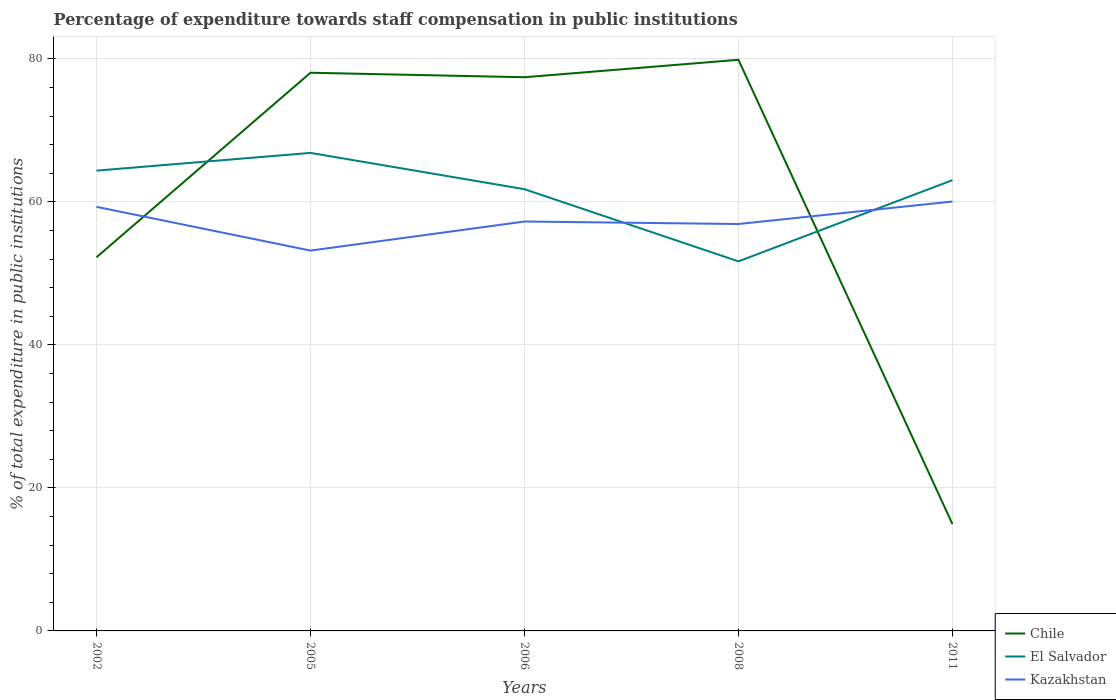How many different coloured lines are there?
Your answer should be very brief. 3. Does the line corresponding to El Salvador intersect with the line corresponding to Chile?
Offer a very short reply. Yes. Is the number of lines equal to the number of legend labels?
Provide a succinct answer. Yes. Across all years, what is the maximum percentage of expenditure towards staff compensation in Chile?
Offer a terse response. 14.95. In which year was the percentage of expenditure towards staff compensation in Chile maximum?
Make the answer very short. 2011. What is the total percentage of expenditure towards staff compensation in Chile in the graph?
Your answer should be compact. -2.44. What is the difference between the highest and the second highest percentage of expenditure towards staff compensation in Chile?
Your answer should be compact. 64.94. How many lines are there?
Offer a very short reply. 3. How many years are there in the graph?
Give a very brief answer. 5. Are the values on the major ticks of Y-axis written in scientific E-notation?
Your answer should be compact. No. Does the graph contain any zero values?
Your answer should be very brief. No. Does the graph contain grids?
Ensure brevity in your answer.  Yes. Where does the legend appear in the graph?
Provide a succinct answer. Bottom right. How many legend labels are there?
Provide a short and direct response. 3. What is the title of the graph?
Your response must be concise. Percentage of expenditure towards staff compensation in public institutions. Does "Belgium" appear as one of the legend labels in the graph?
Keep it short and to the point. No. What is the label or title of the Y-axis?
Provide a succinct answer. % of total expenditure in public institutions. What is the % of total expenditure in public institutions of Chile in 2002?
Give a very brief answer. 52.27. What is the % of total expenditure in public institutions in El Salvador in 2002?
Your response must be concise. 64.38. What is the % of total expenditure in public institutions of Kazakhstan in 2002?
Ensure brevity in your answer.  59.32. What is the % of total expenditure in public institutions in Chile in 2005?
Provide a short and direct response. 78.08. What is the % of total expenditure in public institutions in El Salvador in 2005?
Provide a succinct answer. 66.86. What is the % of total expenditure in public institutions of Kazakhstan in 2005?
Give a very brief answer. 53.2. What is the % of total expenditure in public institutions in Chile in 2006?
Your response must be concise. 77.45. What is the % of total expenditure in public institutions in El Salvador in 2006?
Provide a succinct answer. 61.79. What is the % of total expenditure in public institutions in Kazakhstan in 2006?
Offer a terse response. 57.27. What is the % of total expenditure in public institutions in Chile in 2008?
Your answer should be very brief. 79.89. What is the % of total expenditure in public institutions in El Salvador in 2008?
Your answer should be very brief. 51.69. What is the % of total expenditure in public institutions in Kazakhstan in 2008?
Offer a terse response. 56.92. What is the % of total expenditure in public institutions in Chile in 2011?
Ensure brevity in your answer.  14.95. What is the % of total expenditure in public institutions of El Salvador in 2011?
Keep it short and to the point. 63.05. What is the % of total expenditure in public institutions in Kazakhstan in 2011?
Ensure brevity in your answer.  60.06. Across all years, what is the maximum % of total expenditure in public institutions in Chile?
Provide a succinct answer. 79.89. Across all years, what is the maximum % of total expenditure in public institutions in El Salvador?
Ensure brevity in your answer.  66.86. Across all years, what is the maximum % of total expenditure in public institutions in Kazakhstan?
Your response must be concise. 60.06. Across all years, what is the minimum % of total expenditure in public institutions of Chile?
Keep it short and to the point. 14.95. Across all years, what is the minimum % of total expenditure in public institutions in El Salvador?
Provide a short and direct response. 51.69. Across all years, what is the minimum % of total expenditure in public institutions of Kazakhstan?
Ensure brevity in your answer.  53.2. What is the total % of total expenditure in public institutions of Chile in the graph?
Your answer should be compact. 302.63. What is the total % of total expenditure in public institutions in El Salvador in the graph?
Provide a short and direct response. 307.77. What is the total % of total expenditure in public institutions in Kazakhstan in the graph?
Ensure brevity in your answer.  286.76. What is the difference between the % of total expenditure in public institutions of Chile in 2002 and that in 2005?
Your response must be concise. -25.81. What is the difference between the % of total expenditure in public institutions of El Salvador in 2002 and that in 2005?
Your answer should be compact. -2.48. What is the difference between the % of total expenditure in public institutions in Kazakhstan in 2002 and that in 2005?
Ensure brevity in your answer.  6.12. What is the difference between the % of total expenditure in public institutions in Chile in 2002 and that in 2006?
Provide a short and direct response. -25.18. What is the difference between the % of total expenditure in public institutions of El Salvador in 2002 and that in 2006?
Keep it short and to the point. 2.59. What is the difference between the % of total expenditure in public institutions of Kazakhstan in 2002 and that in 2006?
Your answer should be very brief. 2.05. What is the difference between the % of total expenditure in public institutions of Chile in 2002 and that in 2008?
Give a very brief answer. -27.62. What is the difference between the % of total expenditure in public institutions in El Salvador in 2002 and that in 2008?
Ensure brevity in your answer.  12.69. What is the difference between the % of total expenditure in public institutions in Kazakhstan in 2002 and that in 2008?
Provide a short and direct response. 2.4. What is the difference between the % of total expenditure in public institutions in Chile in 2002 and that in 2011?
Keep it short and to the point. 37.32. What is the difference between the % of total expenditure in public institutions in El Salvador in 2002 and that in 2011?
Provide a short and direct response. 1.33. What is the difference between the % of total expenditure in public institutions of Kazakhstan in 2002 and that in 2011?
Provide a short and direct response. -0.74. What is the difference between the % of total expenditure in public institutions in Chile in 2005 and that in 2006?
Make the answer very short. 0.63. What is the difference between the % of total expenditure in public institutions of El Salvador in 2005 and that in 2006?
Provide a succinct answer. 5.08. What is the difference between the % of total expenditure in public institutions of Kazakhstan in 2005 and that in 2006?
Keep it short and to the point. -4.07. What is the difference between the % of total expenditure in public institutions in Chile in 2005 and that in 2008?
Your response must be concise. -1.81. What is the difference between the % of total expenditure in public institutions of El Salvador in 2005 and that in 2008?
Give a very brief answer. 15.17. What is the difference between the % of total expenditure in public institutions in Kazakhstan in 2005 and that in 2008?
Give a very brief answer. -3.72. What is the difference between the % of total expenditure in public institutions in Chile in 2005 and that in 2011?
Your response must be concise. 63.13. What is the difference between the % of total expenditure in public institutions of El Salvador in 2005 and that in 2011?
Make the answer very short. 3.81. What is the difference between the % of total expenditure in public institutions in Kazakhstan in 2005 and that in 2011?
Offer a very short reply. -6.86. What is the difference between the % of total expenditure in public institutions of Chile in 2006 and that in 2008?
Keep it short and to the point. -2.44. What is the difference between the % of total expenditure in public institutions of El Salvador in 2006 and that in 2008?
Ensure brevity in your answer.  10.09. What is the difference between the % of total expenditure in public institutions in Kazakhstan in 2006 and that in 2008?
Keep it short and to the point. 0.35. What is the difference between the % of total expenditure in public institutions in Chile in 2006 and that in 2011?
Provide a succinct answer. 62.5. What is the difference between the % of total expenditure in public institutions of El Salvador in 2006 and that in 2011?
Give a very brief answer. -1.26. What is the difference between the % of total expenditure in public institutions in Kazakhstan in 2006 and that in 2011?
Provide a short and direct response. -2.8. What is the difference between the % of total expenditure in public institutions in Chile in 2008 and that in 2011?
Your answer should be compact. 64.94. What is the difference between the % of total expenditure in public institutions in El Salvador in 2008 and that in 2011?
Your answer should be very brief. -11.36. What is the difference between the % of total expenditure in public institutions of Kazakhstan in 2008 and that in 2011?
Provide a succinct answer. -3.15. What is the difference between the % of total expenditure in public institutions of Chile in 2002 and the % of total expenditure in public institutions of El Salvador in 2005?
Keep it short and to the point. -14.6. What is the difference between the % of total expenditure in public institutions in Chile in 2002 and the % of total expenditure in public institutions in Kazakhstan in 2005?
Your answer should be very brief. -0.93. What is the difference between the % of total expenditure in public institutions of El Salvador in 2002 and the % of total expenditure in public institutions of Kazakhstan in 2005?
Make the answer very short. 11.18. What is the difference between the % of total expenditure in public institutions in Chile in 2002 and the % of total expenditure in public institutions in El Salvador in 2006?
Provide a succinct answer. -9.52. What is the difference between the % of total expenditure in public institutions of Chile in 2002 and the % of total expenditure in public institutions of Kazakhstan in 2006?
Offer a very short reply. -5. What is the difference between the % of total expenditure in public institutions of El Salvador in 2002 and the % of total expenditure in public institutions of Kazakhstan in 2006?
Give a very brief answer. 7.12. What is the difference between the % of total expenditure in public institutions of Chile in 2002 and the % of total expenditure in public institutions of El Salvador in 2008?
Offer a terse response. 0.58. What is the difference between the % of total expenditure in public institutions in Chile in 2002 and the % of total expenditure in public institutions in Kazakhstan in 2008?
Make the answer very short. -4.65. What is the difference between the % of total expenditure in public institutions of El Salvador in 2002 and the % of total expenditure in public institutions of Kazakhstan in 2008?
Provide a succinct answer. 7.46. What is the difference between the % of total expenditure in public institutions of Chile in 2002 and the % of total expenditure in public institutions of El Salvador in 2011?
Ensure brevity in your answer.  -10.78. What is the difference between the % of total expenditure in public institutions of Chile in 2002 and the % of total expenditure in public institutions of Kazakhstan in 2011?
Your response must be concise. -7.79. What is the difference between the % of total expenditure in public institutions of El Salvador in 2002 and the % of total expenditure in public institutions of Kazakhstan in 2011?
Your answer should be very brief. 4.32. What is the difference between the % of total expenditure in public institutions of Chile in 2005 and the % of total expenditure in public institutions of El Salvador in 2006?
Your answer should be very brief. 16.29. What is the difference between the % of total expenditure in public institutions in Chile in 2005 and the % of total expenditure in public institutions in Kazakhstan in 2006?
Offer a terse response. 20.81. What is the difference between the % of total expenditure in public institutions of El Salvador in 2005 and the % of total expenditure in public institutions of Kazakhstan in 2006?
Your response must be concise. 9.6. What is the difference between the % of total expenditure in public institutions of Chile in 2005 and the % of total expenditure in public institutions of El Salvador in 2008?
Keep it short and to the point. 26.39. What is the difference between the % of total expenditure in public institutions of Chile in 2005 and the % of total expenditure in public institutions of Kazakhstan in 2008?
Keep it short and to the point. 21.16. What is the difference between the % of total expenditure in public institutions of El Salvador in 2005 and the % of total expenditure in public institutions of Kazakhstan in 2008?
Your answer should be very brief. 9.95. What is the difference between the % of total expenditure in public institutions in Chile in 2005 and the % of total expenditure in public institutions in El Salvador in 2011?
Offer a very short reply. 15.03. What is the difference between the % of total expenditure in public institutions in Chile in 2005 and the % of total expenditure in public institutions in Kazakhstan in 2011?
Keep it short and to the point. 18.02. What is the difference between the % of total expenditure in public institutions in El Salvador in 2005 and the % of total expenditure in public institutions in Kazakhstan in 2011?
Give a very brief answer. 6.8. What is the difference between the % of total expenditure in public institutions in Chile in 2006 and the % of total expenditure in public institutions in El Salvador in 2008?
Give a very brief answer. 25.76. What is the difference between the % of total expenditure in public institutions of Chile in 2006 and the % of total expenditure in public institutions of Kazakhstan in 2008?
Give a very brief answer. 20.53. What is the difference between the % of total expenditure in public institutions of El Salvador in 2006 and the % of total expenditure in public institutions of Kazakhstan in 2008?
Offer a terse response. 4.87. What is the difference between the % of total expenditure in public institutions of Chile in 2006 and the % of total expenditure in public institutions of El Salvador in 2011?
Keep it short and to the point. 14.4. What is the difference between the % of total expenditure in public institutions of Chile in 2006 and the % of total expenditure in public institutions of Kazakhstan in 2011?
Ensure brevity in your answer.  17.39. What is the difference between the % of total expenditure in public institutions of El Salvador in 2006 and the % of total expenditure in public institutions of Kazakhstan in 2011?
Give a very brief answer. 1.72. What is the difference between the % of total expenditure in public institutions in Chile in 2008 and the % of total expenditure in public institutions in El Salvador in 2011?
Make the answer very short. 16.84. What is the difference between the % of total expenditure in public institutions of Chile in 2008 and the % of total expenditure in public institutions of Kazakhstan in 2011?
Your answer should be very brief. 19.83. What is the difference between the % of total expenditure in public institutions in El Salvador in 2008 and the % of total expenditure in public institutions in Kazakhstan in 2011?
Your response must be concise. -8.37. What is the average % of total expenditure in public institutions of Chile per year?
Provide a succinct answer. 60.53. What is the average % of total expenditure in public institutions in El Salvador per year?
Give a very brief answer. 61.55. What is the average % of total expenditure in public institutions of Kazakhstan per year?
Your response must be concise. 57.35. In the year 2002, what is the difference between the % of total expenditure in public institutions in Chile and % of total expenditure in public institutions in El Salvador?
Make the answer very short. -12.11. In the year 2002, what is the difference between the % of total expenditure in public institutions in Chile and % of total expenditure in public institutions in Kazakhstan?
Your answer should be very brief. -7.05. In the year 2002, what is the difference between the % of total expenditure in public institutions in El Salvador and % of total expenditure in public institutions in Kazakhstan?
Your response must be concise. 5.06. In the year 2005, what is the difference between the % of total expenditure in public institutions of Chile and % of total expenditure in public institutions of El Salvador?
Your answer should be very brief. 11.21. In the year 2005, what is the difference between the % of total expenditure in public institutions in Chile and % of total expenditure in public institutions in Kazakhstan?
Provide a succinct answer. 24.88. In the year 2005, what is the difference between the % of total expenditure in public institutions of El Salvador and % of total expenditure in public institutions of Kazakhstan?
Your answer should be compact. 13.67. In the year 2006, what is the difference between the % of total expenditure in public institutions of Chile and % of total expenditure in public institutions of El Salvador?
Your answer should be very brief. 15.66. In the year 2006, what is the difference between the % of total expenditure in public institutions in Chile and % of total expenditure in public institutions in Kazakhstan?
Make the answer very short. 20.18. In the year 2006, what is the difference between the % of total expenditure in public institutions of El Salvador and % of total expenditure in public institutions of Kazakhstan?
Provide a short and direct response. 4.52. In the year 2008, what is the difference between the % of total expenditure in public institutions in Chile and % of total expenditure in public institutions in El Salvador?
Your answer should be compact. 28.2. In the year 2008, what is the difference between the % of total expenditure in public institutions of Chile and % of total expenditure in public institutions of Kazakhstan?
Keep it short and to the point. 22.97. In the year 2008, what is the difference between the % of total expenditure in public institutions of El Salvador and % of total expenditure in public institutions of Kazakhstan?
Offer a very short reply. -5.22. In the year 2011, what is the difference between the % of total expenditure in public institutions in Chile and % of total expenditure in public institutions in El Salvador?
Your answer should be compact. -48.1. In the year 2011, what is the difference between the % of total expenditure in public institutions of Chile and % of total expenditure in public institutions of Kazakhstan?
Provide a short and direct response. -45.11. In the year 2011, what is the difference between the % of total expenditure in public institutions in El Salvador and % of total expenditure in public institutions in Kazakhstan?
Make the answer very short. 2.99. What is the ratio of the % of total expenditure in public institutions of Chile in 2002 to that in 2005?
Offer a very short reply. 0.67. What is the ratio of the % of total expenditure in public institutions of El Salvador in 2002 to that in 2005?
Your answer should be compact. 0.96. What is the ratio of the % of total expenditure in public institutions in Kazakhstan in 2002 to that in 2005?
Provide a succinct answer. 1.11. What is the ratio of the % of total expenditure in public institutions in Chile in 2002 to that in 2006?
Offer a terse response. 0.67. What is the ratio of the % of total expenditure in public institutions in El Salvador in 2002 to that in 2006?
Make the answer very short. 1.04. What is the ratio of the % of total expenditure in public institutions of Kazakhstan in 2002 to that in 2006?
Ensure brevity in your answer.  1.04. What is the ratio of the % of total expenditure in public institutions in Chile in 2002 to that in 2008?
Provide a succinct answer. 0.65. What is the ratio of the % of total expenditure in public institutions of El Salvador in 2002 to that in 2008?
Offer a terse response. 1.25. What is the ratio of the % of total expenditure in public institutions in Kazakhstan in 2002 to that in 2008?
Make the answer very short. 1.04. What is the ratio of the % of total expenditure in public institutions in Chile in 2002 to that in 2011?
Keep it short and to the point. 3.5. What is the ratio of the % of total expenditure in public institutions of El Salvador in 2002 to that in 2011?
Your answer should be compact. 1.02. What is the ratio of the % of total expenditure in public institutions of Kazakhstan in 2002 to that in 2011?
Ensure brevity in your answer.  0.99. What is the ratio of the % of total expenditure in public institutions of Chile in 2005 to that in 2006?
Offer a terse response. 1.01. What is the ratio of the % of total expenditure in public institutions in El Salvador in 2005 to that in 2006?
Offer a terse response. 1.08. What is the ratio of the % of total expenditure in public institutions in Kazakhstan in 2005 to that in 2006?
Ensure brevity in your answer.  0.93. What is the ratio of the % of total expenditure in public institutions in Chile in 2005 to that in 2008?
Offer a terse response. 0.98. What is the ratio of the % of total expenditure in public institutions in El Salvador in 2005 to that in 2008?
Your answer should be compact. 1.29. What is the ratio of the % of total expenditure in public institutions of Kazakhstan in 2005 to that in 2008?
Your answer should be compact. 0.93. What is the ratio of the % of total expenditure in public institutions in Chile in 2005 to that in 2011?
Make the answer very short. 5.22. What is the ratio of the % of total expenditure in public institutions in El Salvador in 2005 to that in 2011?
Provide a succinct answer. 1.06. What is the ratio of the % of total expenditure in public institutions in Kazakhstan in 2005 to that in 2011?
Your answer should be very brief. 0.89. What is the ratio of the % of total expenditure in public institutions in Chile in 2006 to that in 2008?
Your answer should be compact. 0.97. What is the ratio of the % of total expenditure in public institutions in El Salvador in 2006 to that in 2008?
Your answer should be very brief. 1.2. What is the ratio of the % of total expenditure in public institutions in Chile in 2006 to that in 2011?
Offer a terse response. 5.18. What is the ratio of the % of total expenditure in public institutions of Kazakhstan in 2006 to that in 2011?
Keep it short and to the point. 0.95. What is the ratio of the % of total expenditure in public institutions of Chile in 2008 to that in 2011?
Your response must be concise. 5.34. What is the ratio of the % of total expenditure in public institutions of El Salvador in 2008 to that in 2011?
Ensure brevity in your answer.  0.82. What is the ratio of the % of total expenditure in public institutions in Kazakhstan in 2008 to that in 2011?
Provide a succinct answer. 0.95. What is the difference between the highest and the second highest % of total expenditure in public institutions of Chile?
Give a very brief answer. 1.81. What is the difference between the highest and the second highest % of total expenditure in public institutions in El Salvador?
Make the answer very short. 2.48. What is the difference between the highest and the second highest % of total expenditure in public institutions of Kazakhstan?
Offer a terse response. 0.74. What is the difference between the highest and the lowest % of total expenditure in public institutions in Chile?
Your answer should be very brief. 64.94. What is the difference between the highest and the lowest % of total expenditure in public institutions of El Salvador?
Give a very brief answer. 15.17. What is the difference between the highest and the lowest % of total expenditure in public institutions in Kazakhstan?
Make the answer very short. 6.86. 